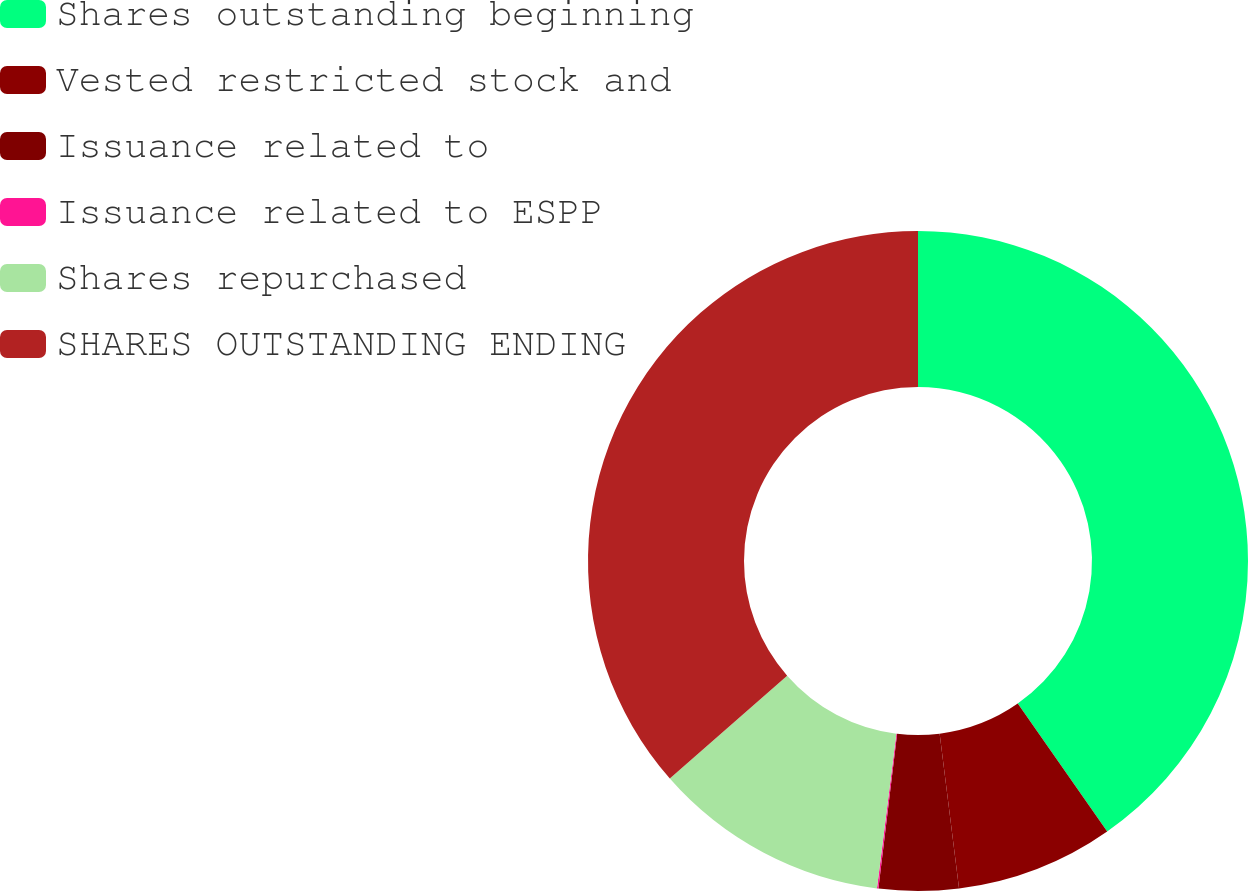Convert chart to OTSL. <chart><loc_0><loc_0><loc_500><loc_500><pie_chart><fcel>Shares outstanding beginning<fcel>Vested restricted stock and<fcel>Issuance related to<fcel>Issuance related to ESPP<fcel>Shares repurchased<fcel>SHARES OUTSTANDING ENDING<nl><fcel>40.28%<fcel>7.73%<fcel>3.9%<fcel>0.07%<fcel>11.56%<fcel>36.45%<nl></chart> 